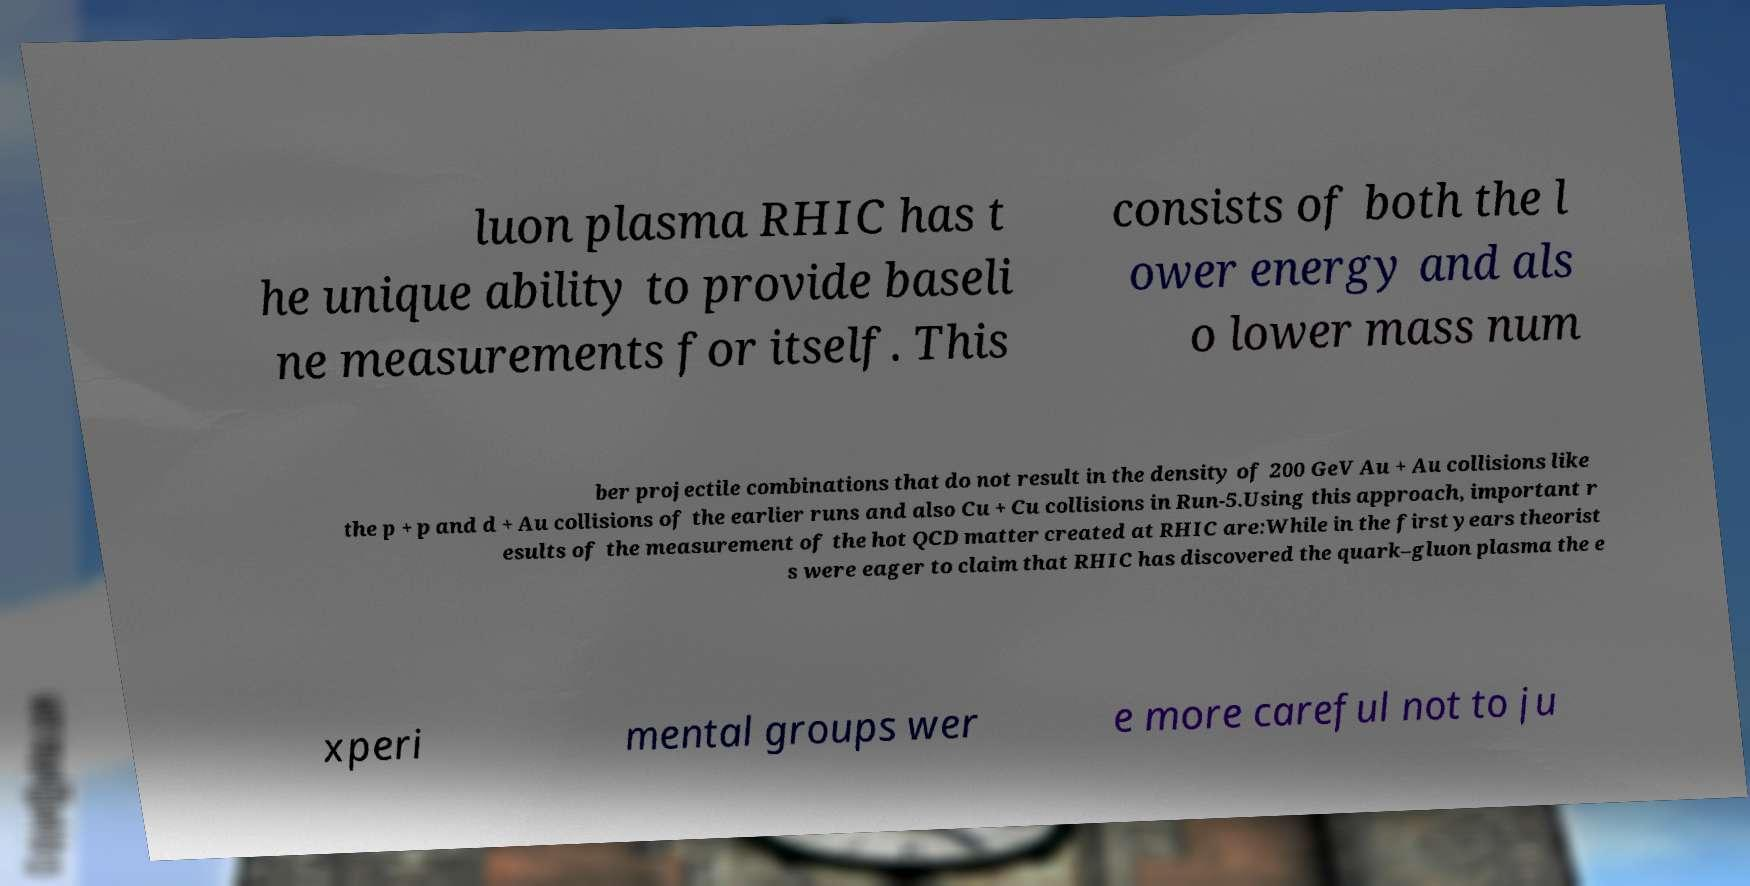There's text embedded in this image that I need extracted. Can you transcribe it verbatim? luon plasma RHIC has t he unique ability to provide baseli ne measurements for itself. This consists of both the l ower energy and als o lower mass num ber projectile combinations that do not result in the density of 200 GeV Au + Au collisions like the p + p and d + Au collisions of the earlier runs and also Cu + Cu collisions in Run-5.Using this approach, important r esults of the measurement of the hot QCD matter created at RHIC are:While in the first years theorist s were eager to claim that RHIC has discovered the quark–gluon plasma the e xperi mental groups wer e more careful not to ju 